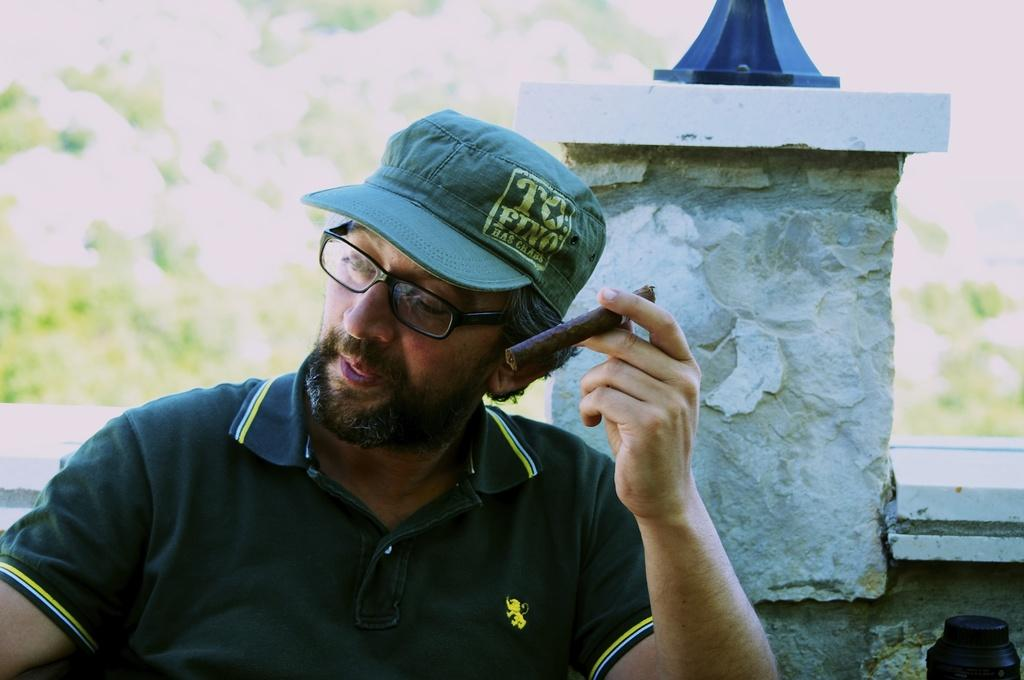What is the main subject of the image? There is a person in the image. What is the person wearing? The person is wearing a t-shirt. What is the person doing in the image? The person is sitting on a chair and holding a cigarette with one hand. Where is the person located in the image? The person is near a wall. How would you describe the background of the image? The background of the image is blurred. What type of calculator is the person using in the image? A: There is no calculator present in the image. What is the condition of the person's health in the image? The image does not provide any information about the person's health condition. 